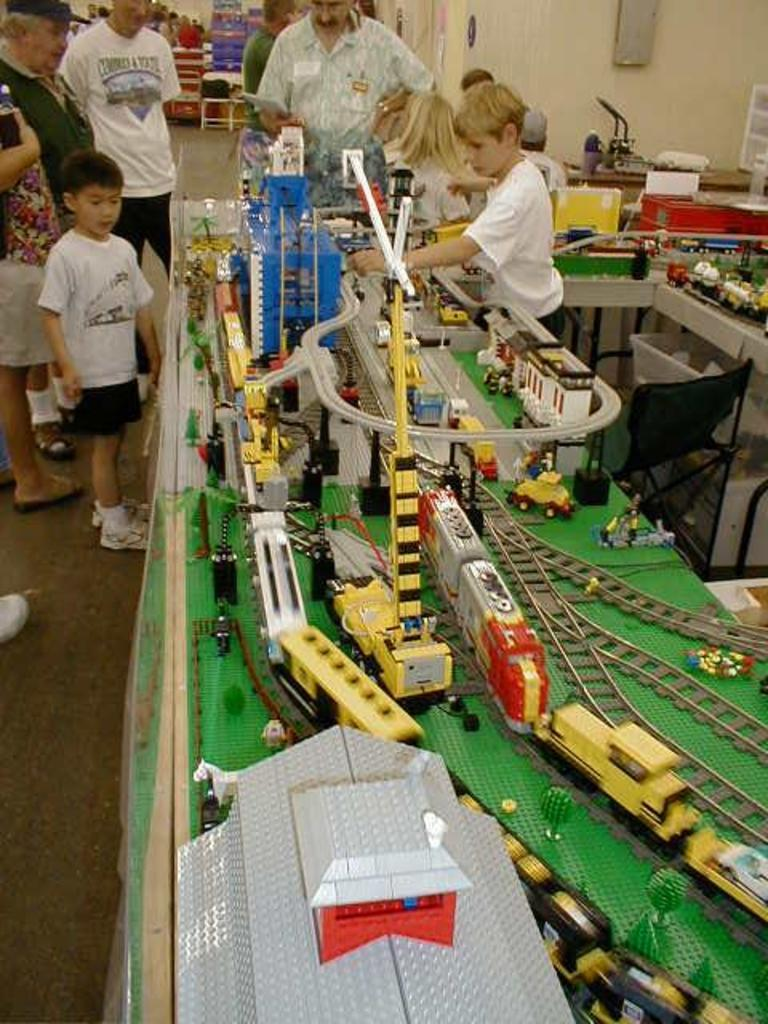What type of toy is present in the image? There are toy trains in the image. What are the toy trains placed on? There are tracks for the toy trains in the image. Can you describe the people in the background of the image? The people in the background are watching the toy trains. What type of border is visible in the image? There is no border present in the image; it features toy trains, tracks, and people watching them. What type of substance is being used by the people in the image? There is no substance use depicted in the image; it shows people watching toy trains on tracks. 